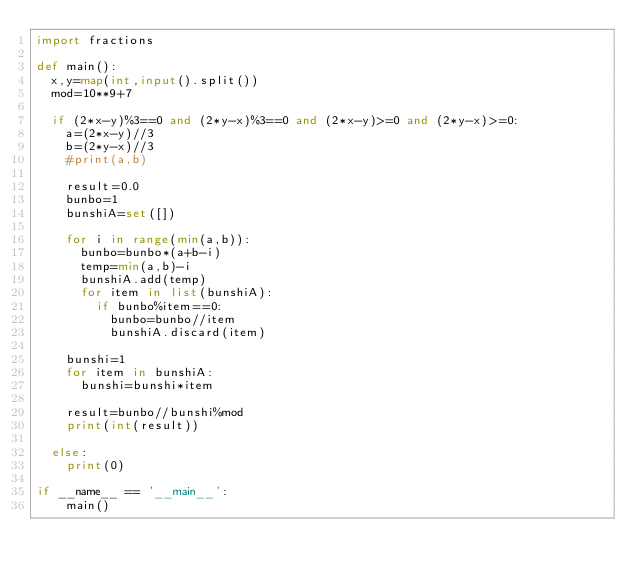<code> <loc_0><loc_0><loc_500><loc_500><_Python_>import fractions

def main():
  x,y=map(int,input().split())
  mod=10**9+7

  if (2*x-y)%3==0 and (2*y-x)%3==0 and (2*x-y)>=0 and (2*y-x)>=0:
    a=(2*x-y)//3
    b=(2*y-x)//3
    #print(a,b)

    result=0.0
    bunbo=1
    bunshiA=set([])

    for i in range(min(a,b)):
      bunbo=bunbo*(a+b-i)
      temp=min(a,b)-i
      bunshiA.add(temp)
      for item in list(bunshiA):
        if bunbo%item==0:
          bunbo=bunbo//item
          bunshiA.discard(item)

    bunshi=1
    for item in bunshiA:
      bunshi=bunshi*item
      
    result=bunbo//bunshi%mod
    print(int(result))

  else:
    print(0)

if __name__ == '__main__':
    main()
</code> 